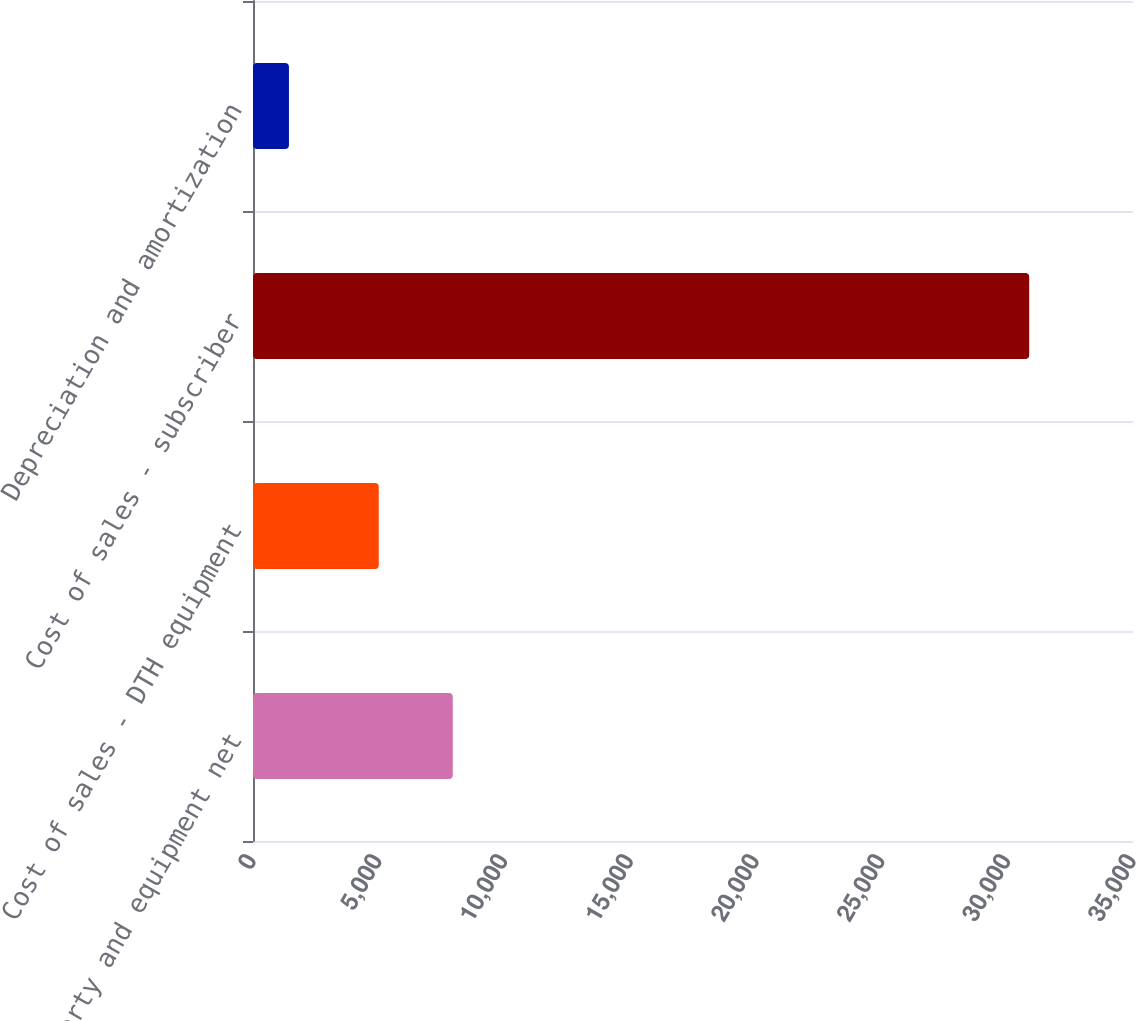<chart> <loc_0><loc_0><loc_500><loc_500><bar_chart><fcel>Property and equipment net<fcel>Cost of sales - DTH equipment<fcel>Cost of sales - subscriber<fcel>Depreciation and amortization<nl><fcel>7946.2<fcel>5002<fcel>30872<fcel>1430<nl></chart> 